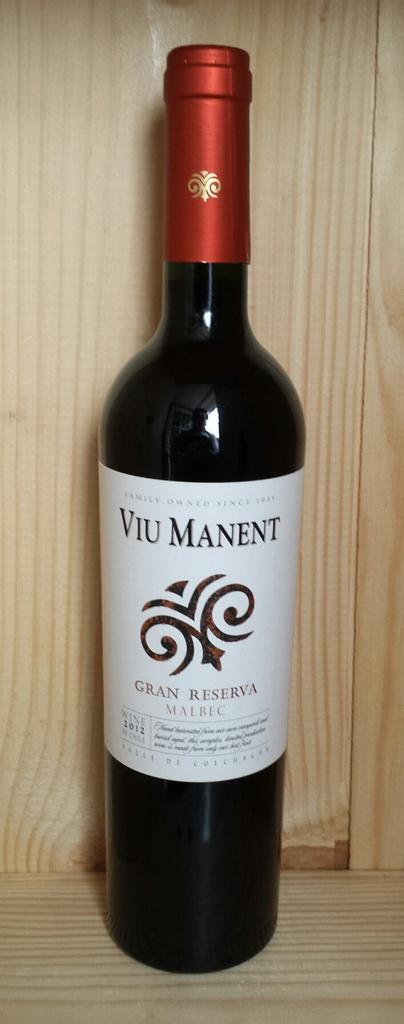<image>
Provide a brief description of the given image. a bottle of wine with Viu Manent written on it. 